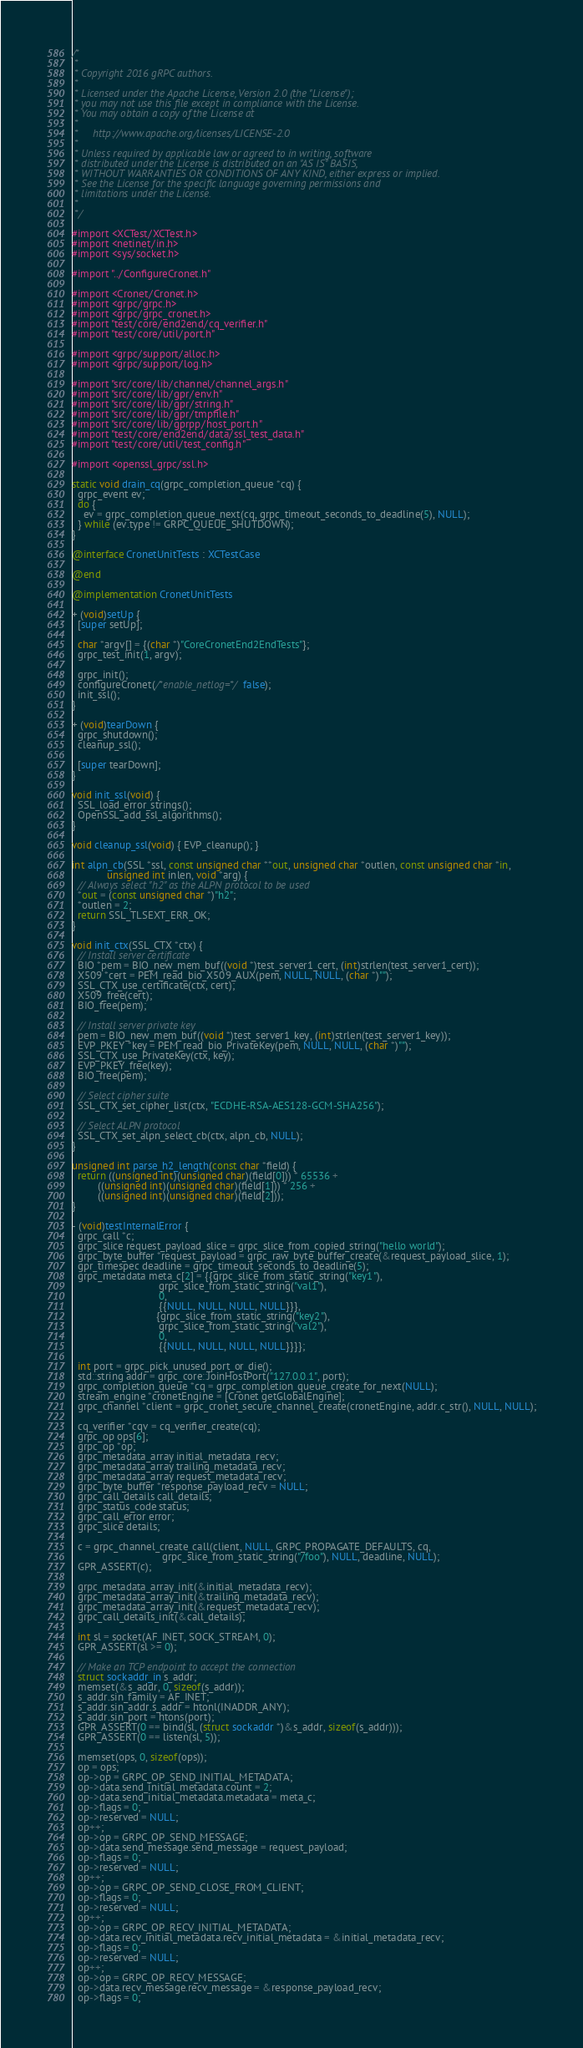<code> <loc_0><loc_0><loc_500><loc_500><_ObjectiveC_>/*
 *
 * Copyright 2016 gRPC authors.
 *
 * Licensed under the Apache License, Version 2.0 (the "License");
 * you may not use this file except in compliance with the License.
 * You may obtain a copy of the License at
 *
 *     http://www.apache.org/licenses/LICENSE-2.0
 *
 * Unless required by applicable law or agreed to in writing, software
 * distributed under the License is distributed on an "AS IS" BASIS,
 * WITHOUT WARRANTIES OR CONDITIONS OF ANY KIND, either express or implied.
 * See the License for the specific language governing permissions and
 * limitations under the License.
 *
 */

#import <XCTest/XCTest.h>
#import <netinet/in.h>
#import <sys/socket.h>

#import "../ConfigureCronet.h"

#import <Cronet/Cronet.h>
#import <grpc/grpc.h>
#import <grpc/grpc_cronet.h>
#import "test/core/end2end/cq_verifier.h"
#import "test/core/util/port.h"

#import <grpc/support/alloc.h>
#import <grpc/support/log.h>

#import "src/core/lib/channel/channel_args.h"
#import "src/core/lib/gpr/env.h"
#import "src/core/lib/gpr/string.h"
#import "src/core/lib/gpr/tmpfile.h"
#import "src/core/lib/gprpp/host_port.h"
#import "test/core/end2end/data/ssl_test_data.h"
#import "test/core/util/test_config.h"

#import <openssl_grpc/ssl.h>

static void drain_cq(grpc_completion_queue *cq) {
  grpc_event ev;
  do {
    ev = grpc_completion_queue_next(cq, grpc_timeout_seconds_to_deadline(5), NULL);
  } while (ev.type != GRPC_QUEUE_SHUTDOWN);
}

@interface CronetUnitTests : XCTestCase

@end

@implementation CronetUnitTests

+ (void)setUp {
  [super setUp];

  char *argv[] = {(char *)"CoreCronetEnd2EndTests"};
  grpc_test_init(1, argv);

  grpc_init();
  configureCronet(/*enable_netlog=*/false);
  init_ssl();
}

+ (void)tearDown {
  grpc_shutdown();
  cleanup_ssl();

  [super tearDown];
}

void init_ssl(void) {
  SSL_load_error_strings();
  OpenSSL_add_ssl_algorithms();
}

void cleanup_ssl(void) { EVP_cleanup(); }

int alpn_cb(SSL *ssl, const unsigned char **out, unsigned char *outlen, const unsigned char *in,
            unsigned int inlen, void *arg) {
  // Always select "h2" as the ALPN protocol to be used
  *out = (const unsigned char *)"h2";
  *outlen = 2;
  return SSL_TLSEXT_ERR_OK;
}

void init_ctx(SSL_CTX *ctx) {
  // Install server certificate
  BIO *pem = BIO_new_mem_buf((void *)test_server1_cert, (int)strlen(test_server1_cert));
  X509 *cert = PEM_read_bio_X509_AUX(pem, NULL, NULL, (char *)"");
  SSL_CTX_use_certificate(ctx, cert);
  X509_free(cert);
  BIO_free(pem);

  // Install server private key
  pem = BIO_new_mem_buf((void *)test_server1_key, (int)strlen(test_server1_key));
  EVP_PKEY *key = PEM_read_bio_PrivateKey(pem, NULL, NULL, (char *)"");
  SSL_CTX_use_PrivateKey(ctx, key);
  EVP_PKEY_free(key);
  BIO_free(pem);

  // Select cipher suite
  SSL_CTX_set_cipher_list(ctx, "ECDHE-RSA-AES128-GCM-SHA256");

  // Select ALPN protocol
  SSL_CTX_set_alpn_select_cb(ctx, alpn_cb, NULL);
}

unsigned int parse_h2_length(const char *field) {
  return ((unsigned int)(unsigned char)(field[0])) * 65536 +
         ((unsigned int)(unsigned char)(field[1])) * 256 +
         ((unsigned int)(unsigned char)(field[2]));
}

- (void)testInternalError {
  grpc_call *c;
  grpc_slice request_payload_slice = grpc_slice_from_copied_string("hello world");
  grpc_byte_buffer *request_payload = grpc_raw_byte_buffer_create(&request_payload_slice, 1);
  gpr_timespec deadline = grpc_timeout_seconds_to_deadline(5);
  grpc_metadata meta_c[2] = {{grpc_slice_from_static_string("key1"),
                              grpc_slice_from_static_string("val1"),
                              0,
                              {{NULL, NULL, NULL, NULL}}},
                             {grpc_slice_from_static_string("key2"),
                              grpc_slice_from_static_string("val2"),
                              0,
                              {{NULL, NULL, NULL, NULL}}}};

  int port = grpc_pick_unused_port_or_die();
  std::string addr = grpc_core::JoinHostPort("127.0.0.1", port);
  grpc_completion_queue *cq = grpc_completion_queue_create_for_next(NULL);
  stream_engine *cronetEngine = [Cronet getGlobalEngine];
  grpc_channel *client = grpc_cronet_secure_channel_create(cronetEngine, addr.c_str(), NULL, NULL);

  cq_verifier *cqv = cq_verifier_create(cq);
  grpc_op ops[6];
  grpc_op *op;
  grpc_metadata_array initial_metadata_recv;
  grpc_metadata_array trailing_metadata_recv;
  grpc_metadata_array request_metadata_recv;
  grpc_byte_buffer *response_payload_recv = NULL;
  grpc_call_details call_details;
  grpc_status_code status;
  grpc_call_error error;
  grpc_slice details;

  c = grpc_channel_create_call(client, NULL, GRPC_PROPAGATE_DEFAULTS, cq,
                               grpc_slice_from_static_string("/foo"), NULL, deadline, NULL);
  GPR_ASSERT(c);

  grpc_metadata_array_init(&initial_metadata_recv);
  grpc_metadata_array_init(&trailing_metadata_recv);
  grpc_metadata_array_init(&request_metadata_recv);
  grpc_call_details_init(&call_details);

  int sl = socket(AF_INET, SOCK_STREAM, 0);
  GPR_ASSERT(sl >= 0);

  // Make an TCP endpoint to accept the connection
  struct sockaddr_in s_addr;
  memset(&s_addr, 0, sizeof(s_addr));
  s_addr.sin_family = AF_INET;
  s_addr.sin_addr.s_addr = htonl(INADDR_ANY);
  s_addr.sin_port = htons(port);
  GPR_ASSERT(0 == bind(sl, (struct sockaddr *)&s_addr, sizeof(s_addr)));
  GPR_ASSERT(0 == listen(sl, 5));

  memset(ops, 0, sizeof(ops));
  op = ops;
  op->op = GRPC_OP_SEND_INITIAL_METADATA;
  op->data.send_initial_metadata.count = 2;
  op->data.send_initial_metadata.metadata = meta_c;
  op->flags = 0;
  op->reserved = NULL;
  op++;
  op->op = GRPC_OP_SEND_MESSAGE;
  op->data.send_message.send_message = request_payload;
  op->flags = 0;
  op->reserved = NULL;
  op++;
  op->op = GRPC_OP_SEND_CLOSE_FROM_CLIENT;
  op->flags = 0;
  op->reserved = NULL;
  op++;
  op->op = GRPC_OP_RECV_INITIAL_METADATA;
  op->data.recv_initial_metadata.recv_initial_metadata = &initial_metadata_recv;
  op->flags = 0;
  op->reserved = NULL;
  op++;
  op->op = GRPC_OP_RECV_MESSAGE;
  op->data.recv_message.recv_message = &response_payload_recv;
  op->flags = 0;</code> 